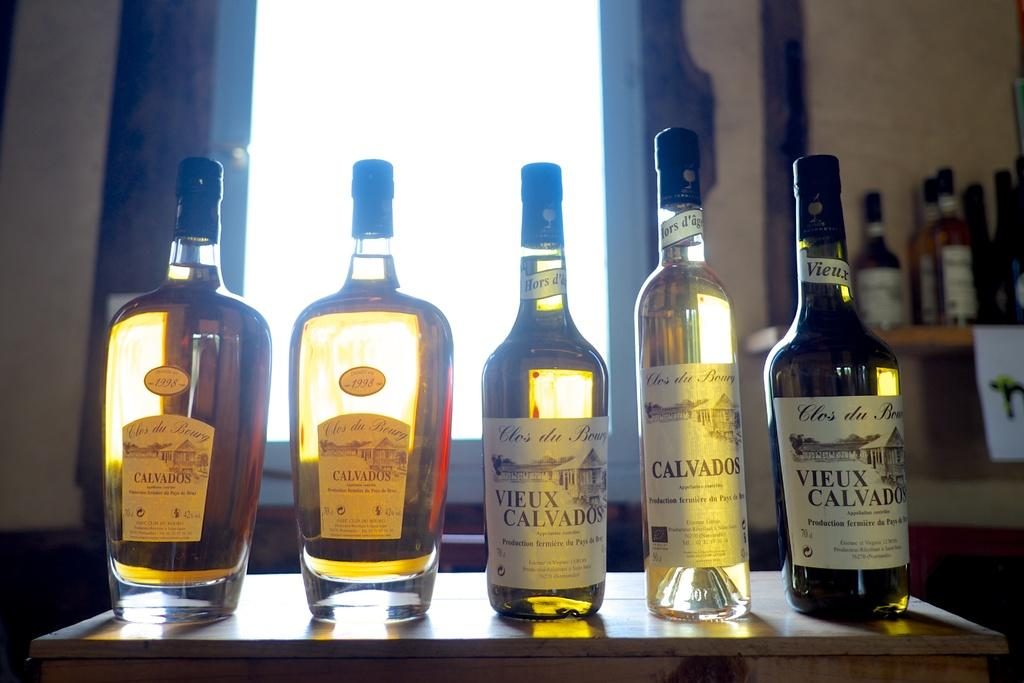<image>
Summarize the visual content of the image. Bottles of alcohol labeled Calvados and Vieux Calvados. 